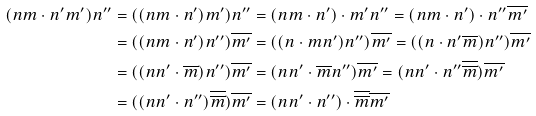Convert formula to latex. <formula><loc_0><loc_0><loc_500><loc_500>( n m \cdot n ^ { \prime } m ^ { \prime } ) n ^ { \prime \prime } & = ( ( n m \cdot n ^ { \prime } ) m ^ { \prime } ) n ^ { \prime \prime } = ( n m \cdot n ^ { \prime } ) \cdot m ^ { \prime } n ^ { \prime \prime } = ( n m \cdot n ^ { \prime } ) \cdot n ^ { \prime \prime } \overline { m ^ { \prime } } \\ & = ( ( n m \cdot n ^ { \prime } ) n ^ { \prime \prime } ) \overline { m ^ { \prime } } = ( ( n \cdot m n ^ { \prime } ) n ^ { \prime \prime } ) \overline { m ^ { \prime } } = ( ( n \cdot n ^ { \prime } \overline { m } ) n ^ { \prime \prime } ) \overline { m ^ { \prime } } \\ & = ( ( n n ^ { \prime } \cdot \overline { m } ) n ^ { \prime \prime } ) \overline { m ^ { \prime } } = ( n n ^ { \prime } \cdot \overline { m } n ^ { \prime \prime } ) \overline { m ^ { \prime } } = ( n n ^ { \prime } \cdot n ^ { \prime \prime } \overline { \overline { m } } ) \overline { m ^ { \prime } } \\ & = ( ( n n ^ { \prime } \cdot n ^ { \prime \prime } ) \overline { \overline { m } } ) \overline { m ^ { \prime } } = ( n n ^ { \prime } \cdot n ^ { \prime \prime } ) \cdot \overline { \overline { m } } \overline { m ^ { \prime } }</formula> 